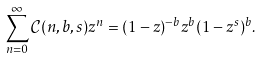Convert formula to latex. <formula><loc_0><loc_0><loc_500><loc_500>\sum _ { n = 0 } ^ { \infty } \mathcal { C } ( n , b , s ) z ^ { n } = ( 1 - z ) ^ { - b } z ^ { b } ( 1 - z ^ { s } ) ^ { b } .</formula> 